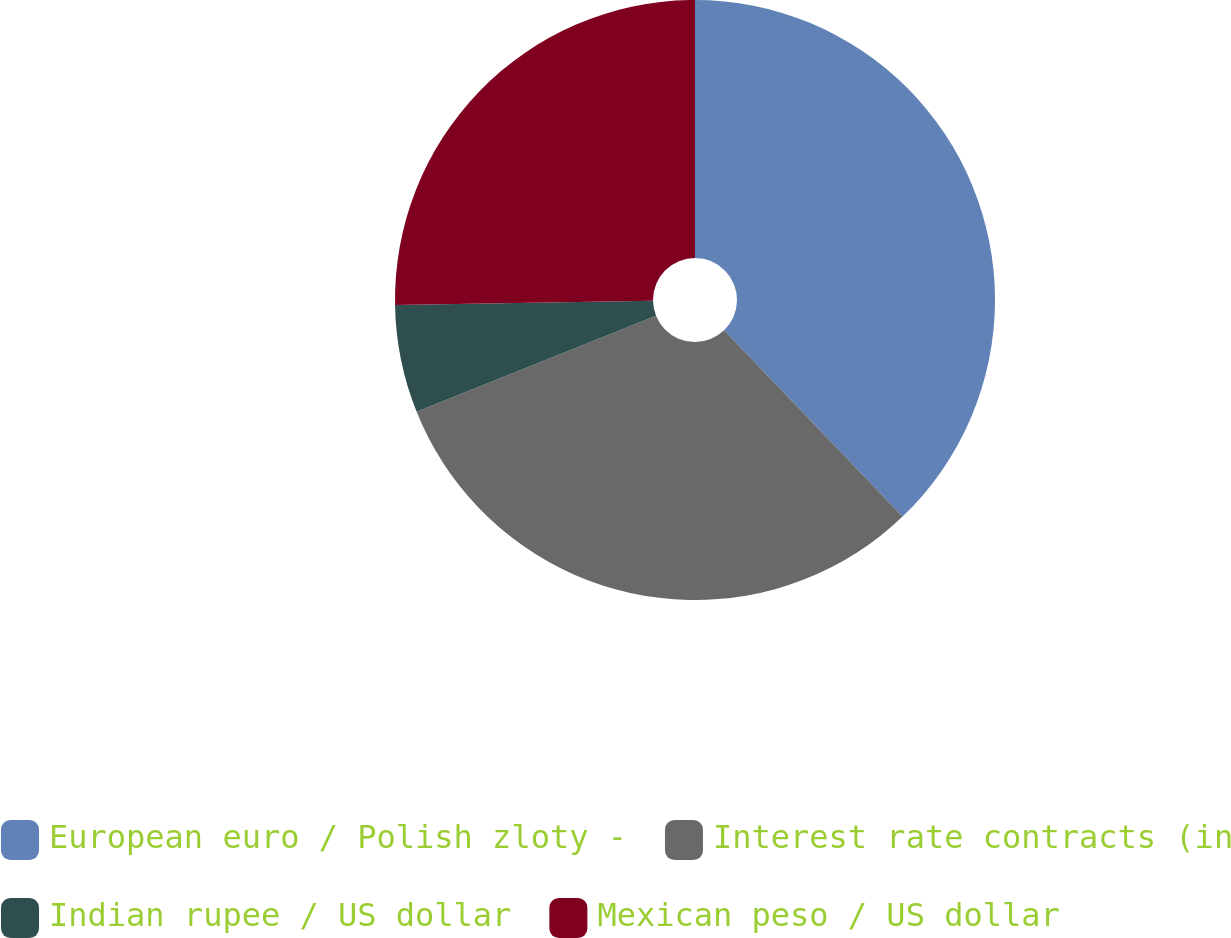Convert chart to OTSL. <chart><loc_0><loc_0><loc_500><loc_500><pie_chart><fcel>European euro / Polish zloty -<fcel>Interest rate contracts (in<fcel>Indian rupee / US dollar<fcel>Mexican peso / US dollar<nl><fcel>37.84%<fcel>31.08%<fcel>5.81%<fcel>25.27%<nl></chart> 